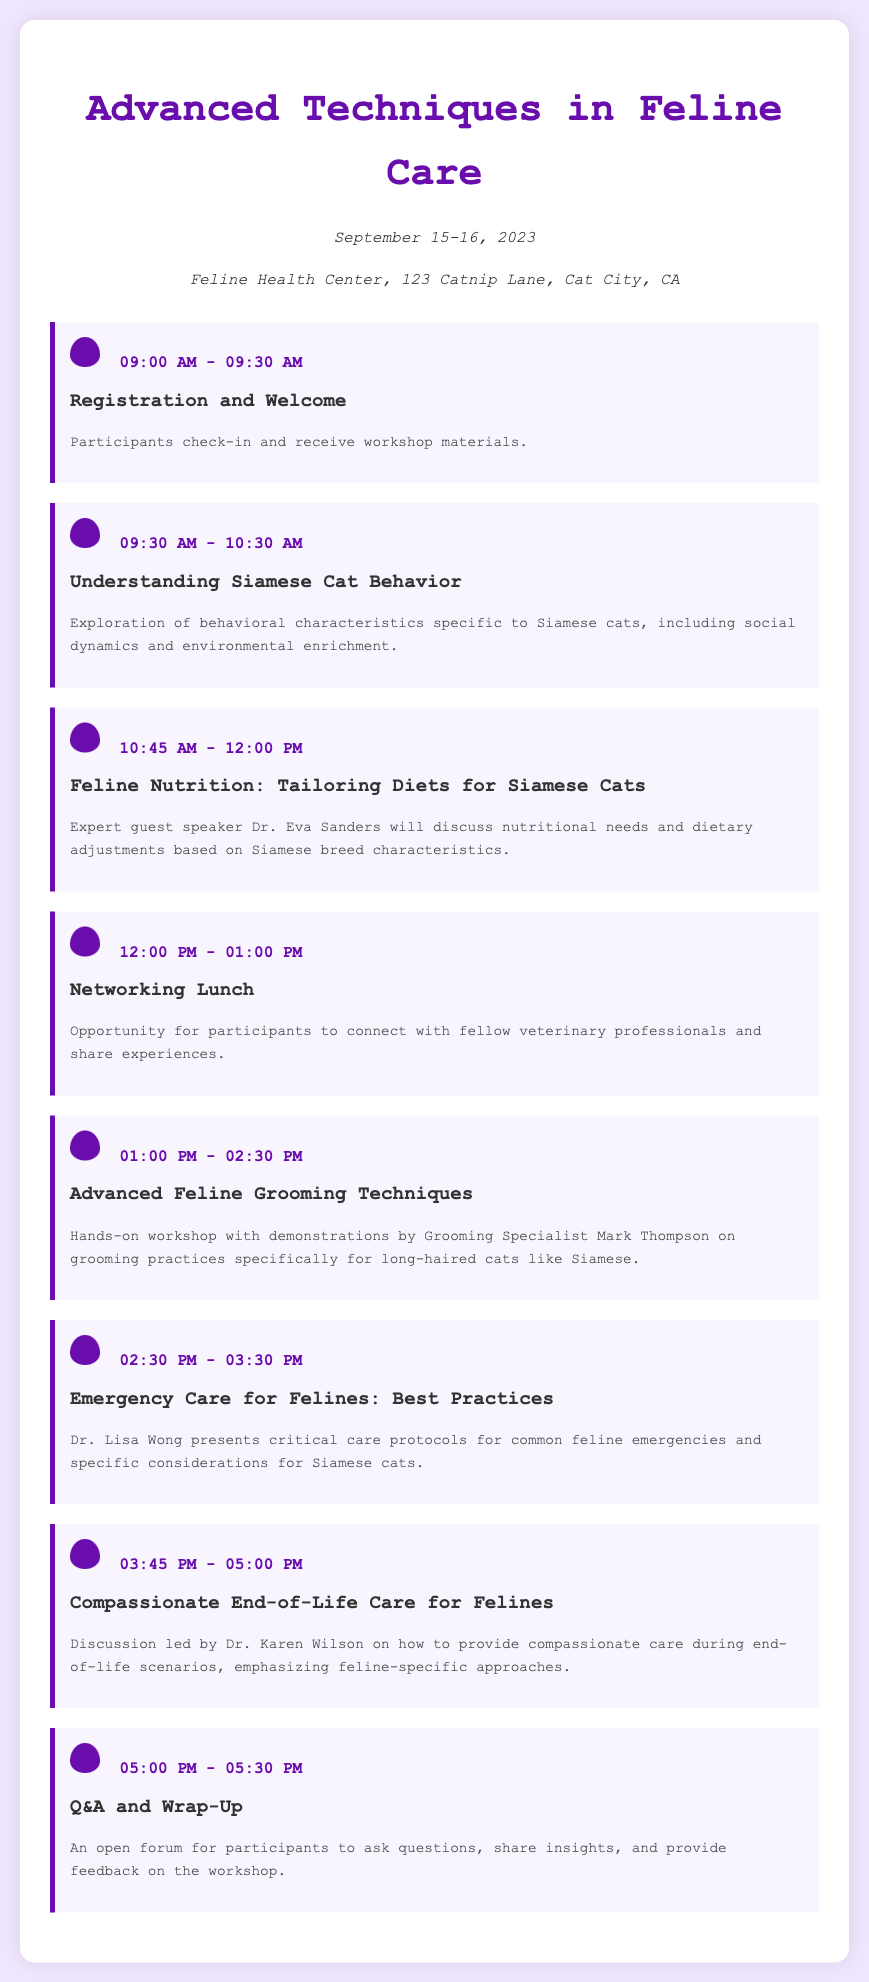What is the date of the workshop? The workshop is scheduled for September 15-16, 2023.
Answer: September 15-16, 2023 Where is the workshop taking place? The workshop will be held at Feline Health Center, 123 Catnip Lane, Cat City, CA.
Answer: Feline Health Center, 123 Catnip Lane, Cat City, CA Who is the guest speaker for the nutrition session? The guest speaker for the session on nutrition is Dr. Eva Sanders.
Answer: Dr. Eva Sanders What time does the Q&A session start? The Q&A and Wrap-Up session begins at 5:00 PM.
Answer: 5:00 PM How long is the session on Advanced Feline Grooming Techniques? The session on grooming techniques lasts for 1 hour and 30 minutes.
Answer: 1 hour and 30 minutes What is the focus of the session on Understanding Siamese Cat Behavior? This session explores behavioral characteristics specific to Siamese cats, including social dynamics and environmental enrichment.
Answer: behavioral characteristics specific to Siamese cats Which session is scheduled after the Networking Lunch? The session that follows the Networking Lunch is titled Advanced Feline Grooming Techniques.
Answer: Advanced Feline Grooming Techniques What is the main topic of Dr. Lisa Wong's presentation? Dr. Lisa Wong's presentation focuses on critical care protocols for common feline emergencies.
Answer: critical care protocols for common feline emergencies What color theme is used in the document? The document features a purple color theme.
Answer: purple color theme 